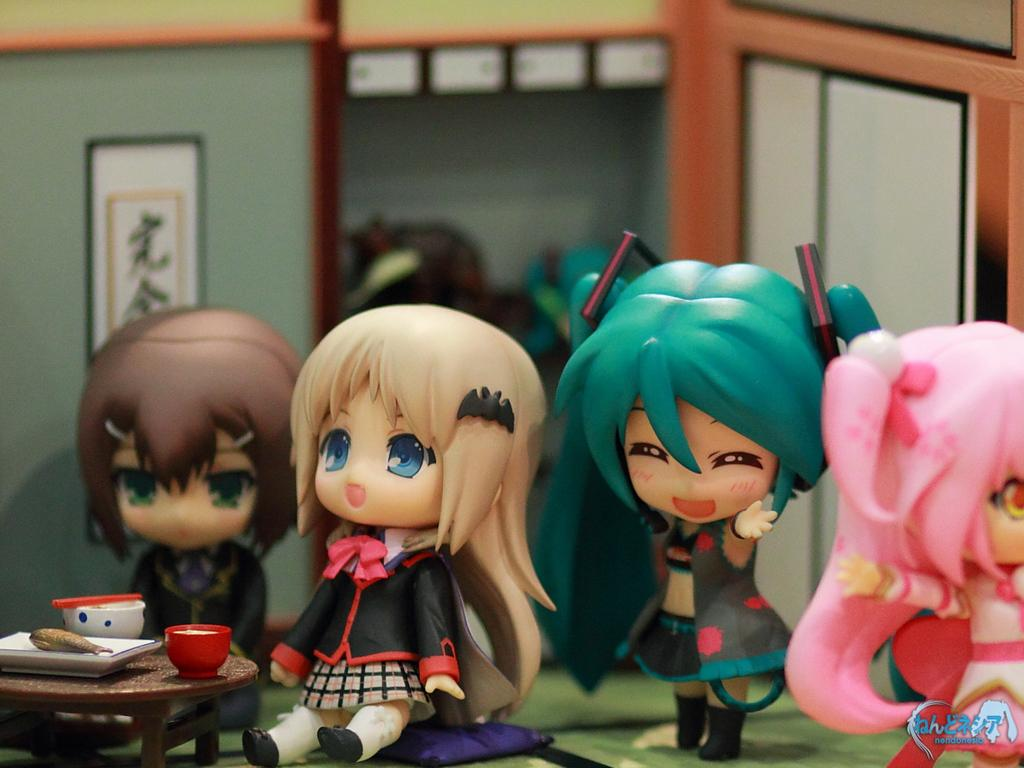How many toy dolls are present in the image? There are four toy dolls in the image. What can be seen in the background of the image? There is a wall visible in the image. What object in the image can be used for self-reflection? There is a mirror in the image. What type of decorative item is hanging in the image? There is a hanging photo frame in the image. Where is the park located in the image? There is no park present in the image. What type of whip is being used by the toy dolls in the image? There are no whips present in the image, and the toy dolls are not using any objects. 